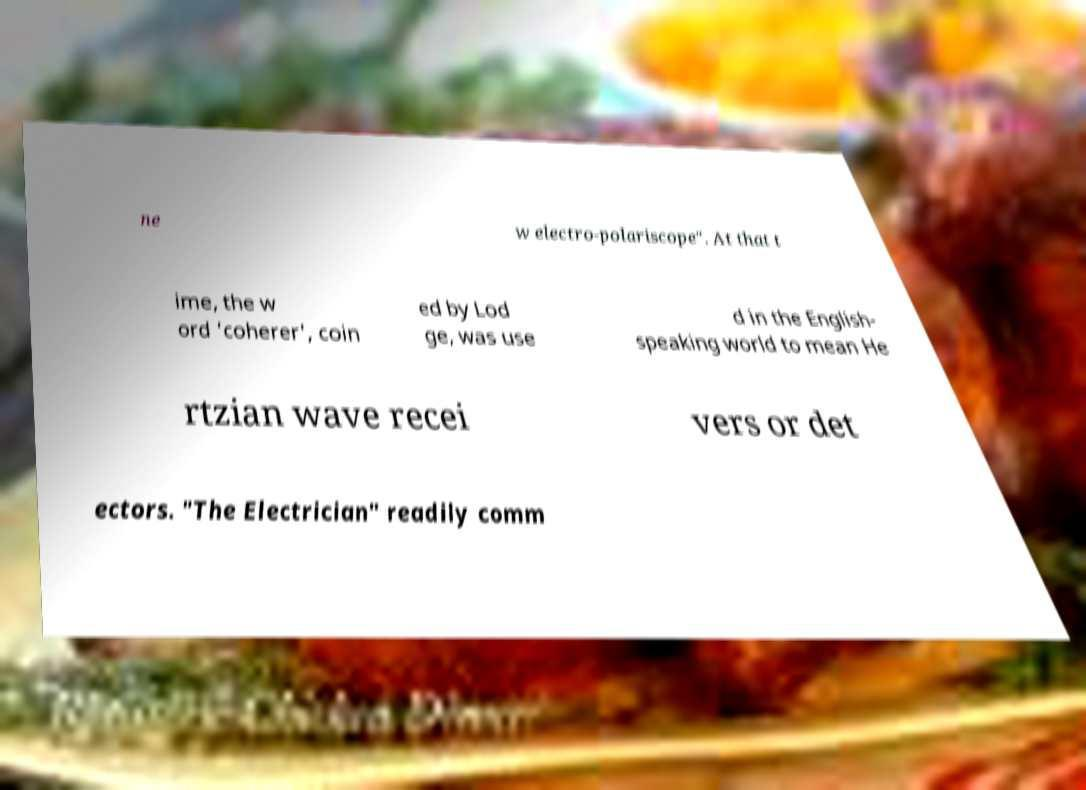There's text embedded in this image that I need extracted. Can you transcribe it verbatim? ne w electro-polariscope". At that t ime, the w ord 'coherer', coin ed by Lod ge, was use d in the English- speaking world to mean He rtzian wave recei vers or det ectors. "The Electrician" readily comm 